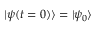Convert formula to latex. <formula><loc_0><loc_0><loc_500><loc_500>| \psi ( t = 0 ) \rangle = | \psi _ { 0 } \rangle</formula> 